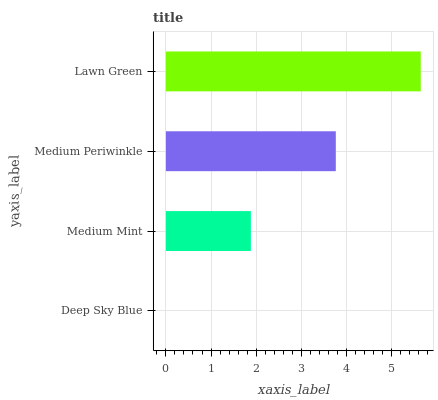Is Deep Sky Blue the minimum?
Answer yes or no. Yes. Is Lawn Green the maximum?
Answer yes or no. Yes. Is Medium Mint the minimum?
Answer yes or no. No. Is Medium Mint the maximum?
Answer yes or no. No. Is Medium Mint greater than Deep Sky Blue?
Answer yes or no. Yes. Is Deep Sky Blue less than Medium Mint?
Answer yes or no. Yes. Is Deep Sky Blue greater than Medium Mint?
Answer yes or no. No. Is Medium Mint less than Deep Sky Blue?
Answer yes or no. No. Is Medium Periwinkle the high median?
Answer yes or no. Yes. Is Medium Mint the low median?
Answer yes or no. Yes. Is Medium Mint the high median?
Answer yes or no. No. Is Medium Periwinkle the low median?
Answer yes or no. No. 